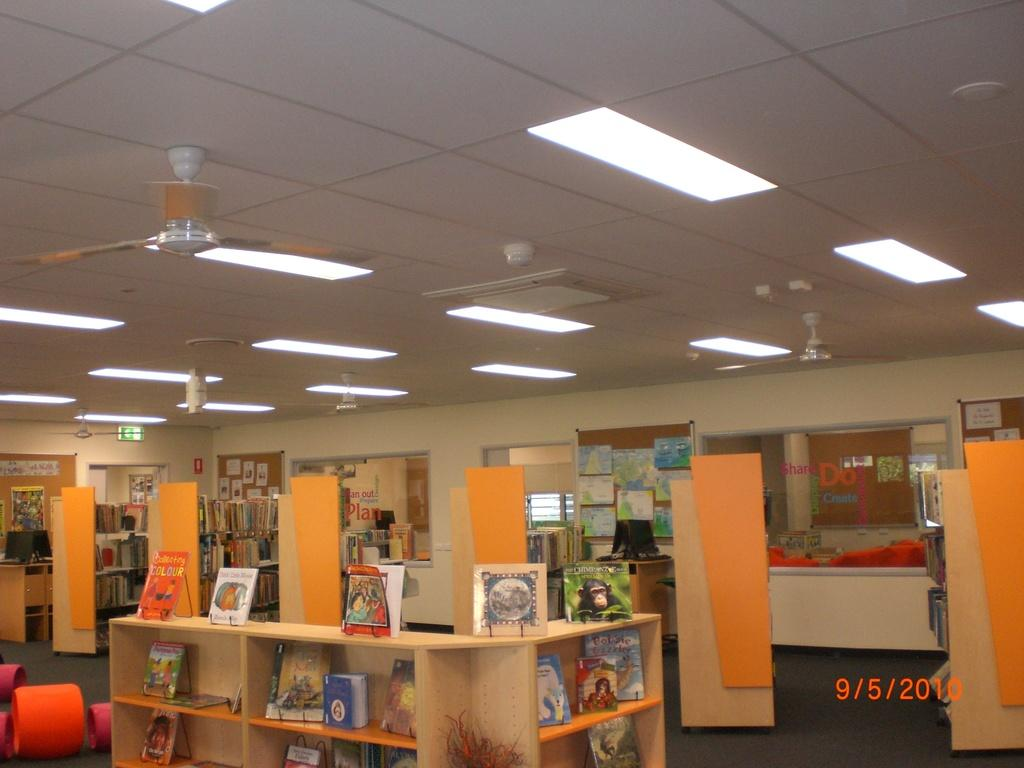What is arranged in shelves in the image? There are books arranged in shelves in the image. What type of electronic devices can be seen in the image? Monitors are visible in the image. What can be seen through the window in the image? The image contains a window, but it is not possible to see through it based on the provided facts. What is used for displaying notices or announcements in the image? There is a notice board in the image. What might be used for circulating air in the image? Fans are present in the image. What is used for illumination in the image? Lights are visible in the image. What is a possible means of entering or exiting the room in the image? There is a door in the image. What is a vertical surface that separates spaces in the image? The image contains a wall. How many hooks are used to hang the books on the shelves in the image? There is no mention of hooks in the image; the books are arranged on shelves. What type of grip does the door handle have in the image? The image does not provide information about the door handle's grip. 